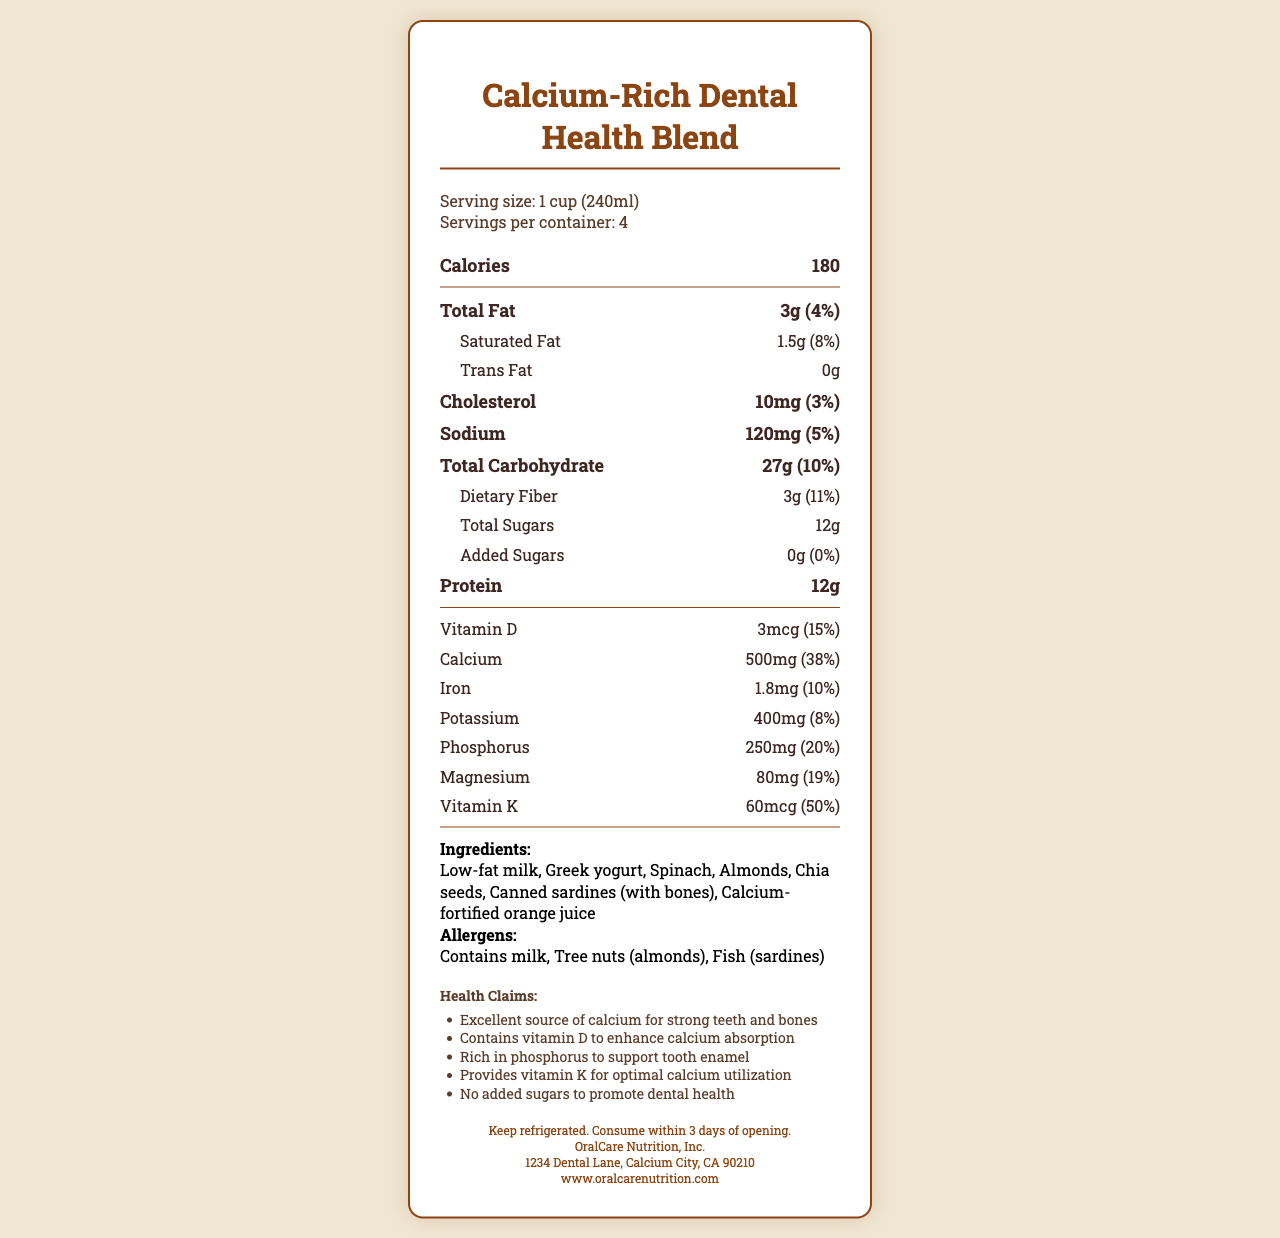what is the serving size? The serving size is listed at the beginning of the document in the serving information section.
Answer: 1 cup (240ml) how many servings are in the entire container? The number of servings per container is specified in the serving information section.
Answer: 4 how many calories are in one serving? The calorie count is listed in the main nutrient information section for one serving.
Answer: 180 how much calcium is in one serving? The amount of calcium per serving is provided in the nutrient section.
Answer: 500mg what is the daily value percentage for calcium? The daily value percentage for calcium is listed in the nutrient section alongside the amount.
Answer: 38% what are the ingredients in this blend? The ingredients are clearly listed in the ingredients section.
Answer: Low-fat milk, Greek yogurt, Spinach, Almonds, Chia seeds, Canned sardines (with bones), Calcium-fortified orange juice which mineral has the highest daily value percentage? A. Iron B. Potassium C. Phosphorus D. Magnesium E. Vitamin K Vitamin K has a daily value percentage of 50%, which is the highest among the listed minerals.
Answer: E what is the amount of dietary fiber in one serving? The amount of dietary fiber is listed in the total carbohydrate section of the nutrient breakdown.
Answer: 3g are there any added sugars in this product? The added sugars section shows 0g and a daily value of 0%.
Answer: No which of the following statements is true? I. The product contains tree nuts. II. The product is free from fish. III. The product contains Greek yogurt. The allergens section states there are tree nuts (almonds) and the list of ingredients includes Greek yogurt. The product does contain fish (sardines).
Answer: I and III should this product be refrigerated? The storage instructions specify that the product should be kept refrigerated.
Answer: Yes is the product suitable for people with lactose intolerance? The product contains milk, which is a source of lactose.
Answer: No does this product have any health benefits related to dental health? The health claims mention it is an excellent source of calcium, contains vitamin D, is rich in phosphorus, provides vitamin K, and has no added sugars, all of which support dental health.
Answer: Yes what company manufactures this product? The manufacturer is listed at the bottom of the document.
Answer: OralCare Nutrition, Inc. summarize the main purpose of this product. The label emphasizes the product's high calcium content and other nutrients that promote dental health, outlines its natural ingredients, and provides guidance on consumption and storage.
Answer: The Calcium-Rich Dental Health Blend is designed to support strong teeth and bones by providing a high amount of calcium along with other essential nutrients like vitamin D, phosphorus, and vitamin K, without added sugars. what is the total amount of protein in the entire container? One serving has 12g of protein, and there are 4 servings per container, so the total is 12g x 4 = 48g.
Answer: 48g which ingredient contributes to the calcium content the most? The document lists the ingredients but does not specify which one contributes the most to the calcium content.
Answer: Cannot be determined 